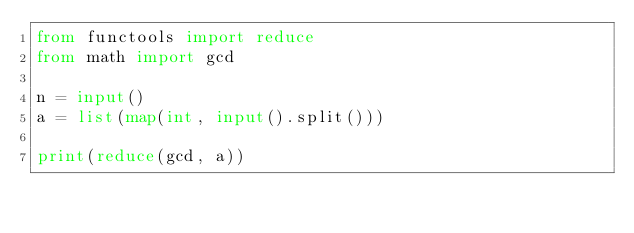Convert code to text. <code><loc_0><loc_0><loc_500><loc_500><_Python_>from functools import reduce
from math import gcd

n = input()
a = list(map(int, input().split()))

print(reduce(gcd, a))
</code> 